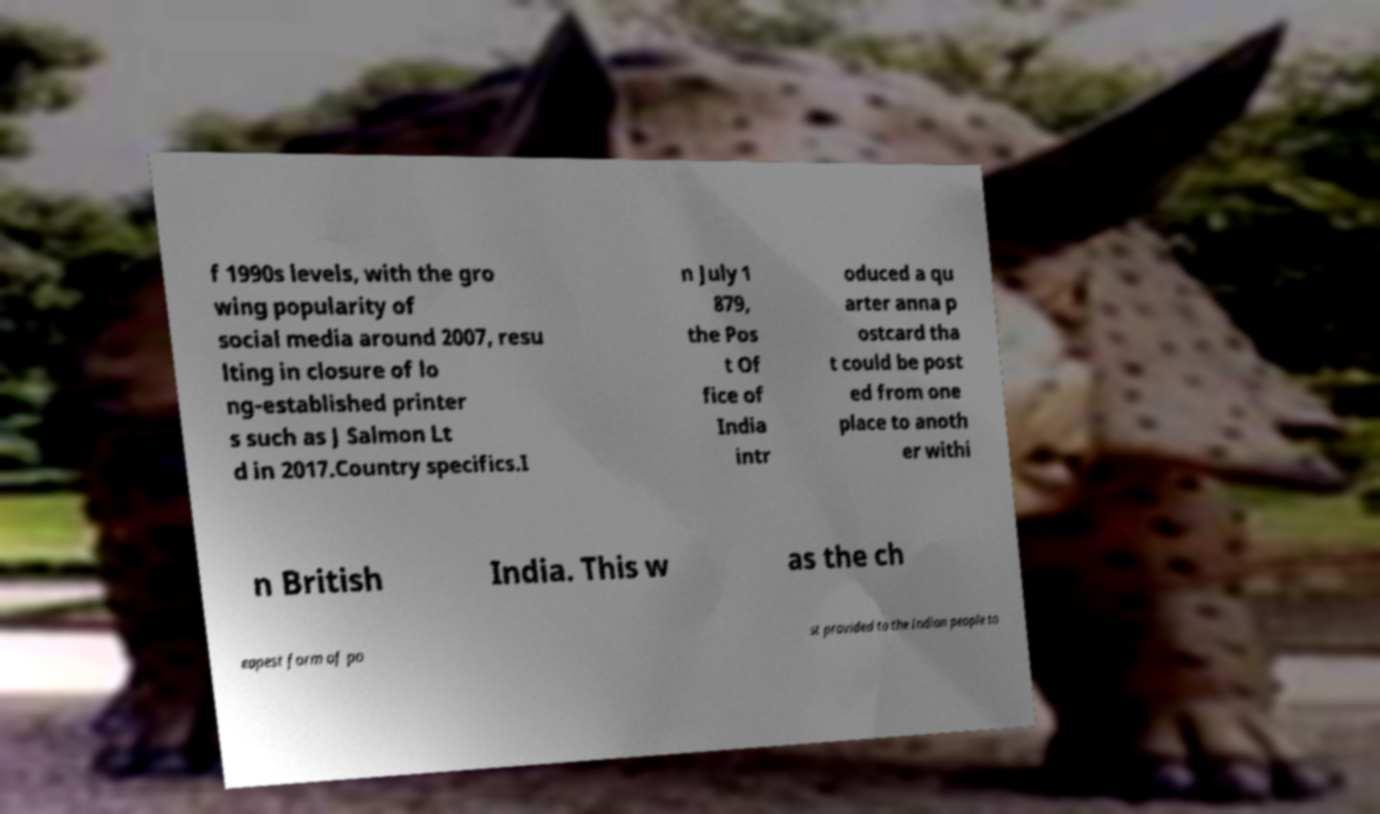For documentation purposes, I need the text within this image transcribed. Could you provide that? f 1990s levels, with the gro wing popularity of social media around 2007, resu lting in closure of lo ng-established printer s such as J Salmon Lt d in 2017.Country specifics.I n July 1 879, the Pos t Of fice of India intr oduced a qu arter anna p ostcard tha t could be post ed from one place to anoth er withi n British India. This w as the ch eapest form of po st provided to the Indian people to 